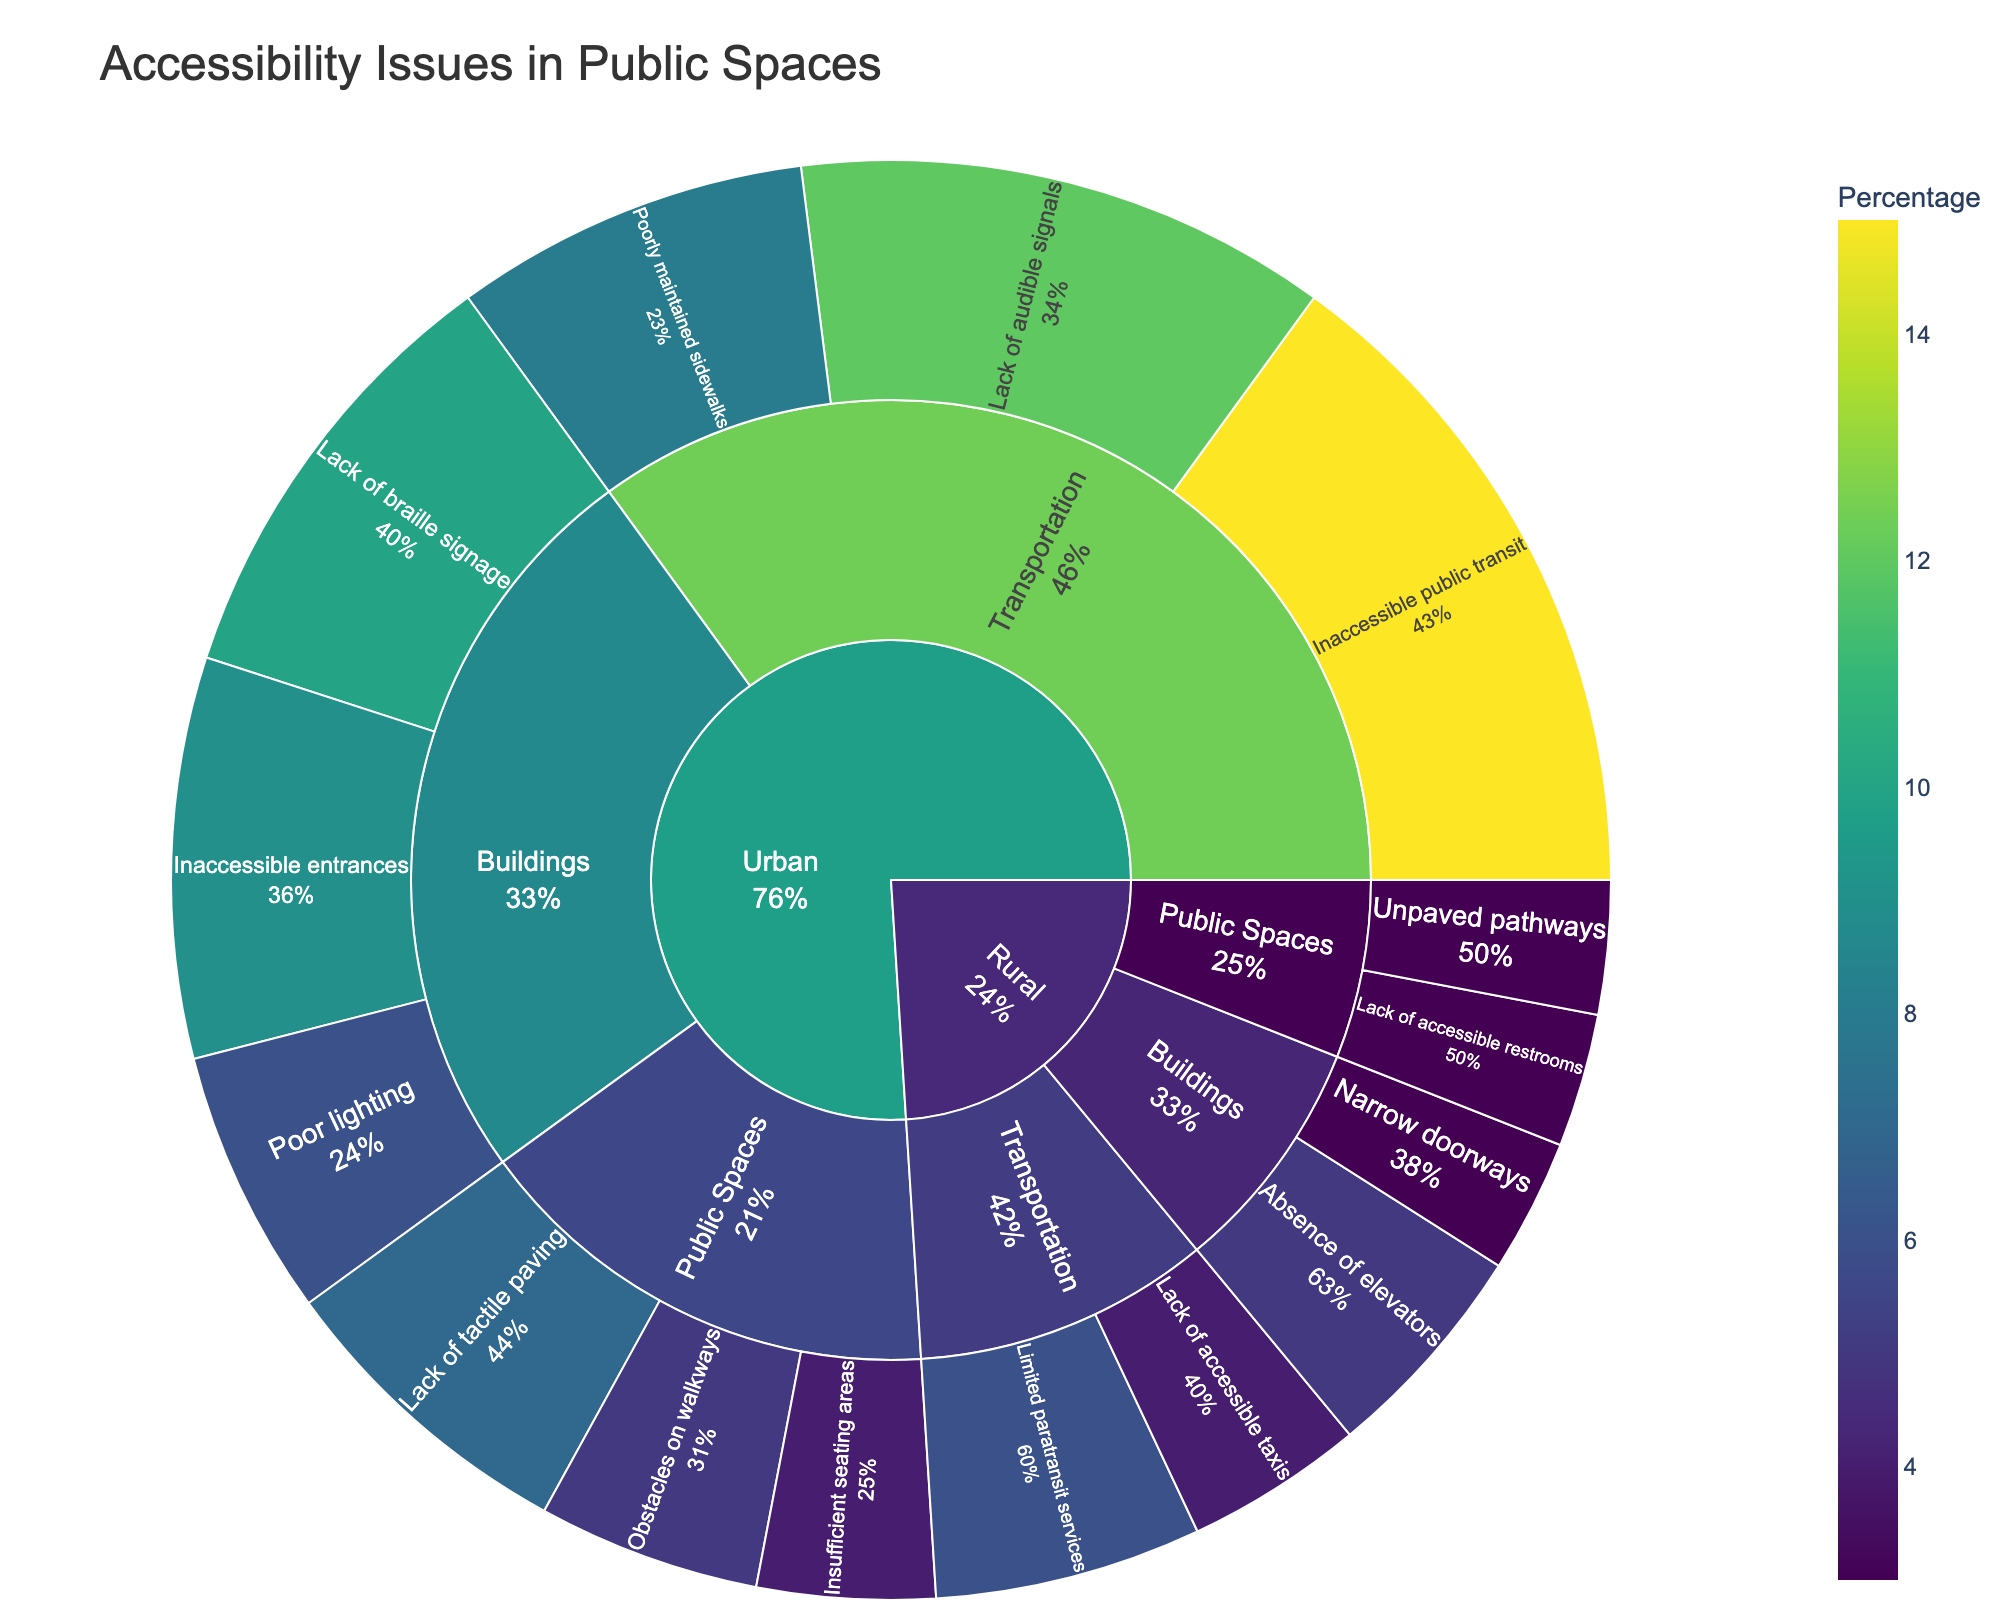What is the title of the plot? The title of the plot is displayed prominently at the top of the figure. It reads "Accessibility Issues in Public Spaces".
Answer: Accessibility Issues in Public Spaces Which location has the highest percentage of accessibility issues in public spaces, Urban or Rural? From the plot, you can observe that Urban areas have multiple categories and specific barriers leading to higher overall percentages compared to Rural areas. Adding up the values for Urban gives a higher total.
Answer: Urban What specific barrier has the highest percentage in the Transportation category in urban areas? In the Transportation category within Urban areas, the specific barrier with the highest percentage is "Inaccessible public transit" at 15%. You can identify this by tracing through the plot from Urban -> Transportation -> Inaccessible public transit.
Answer: Inaccessible public transit In Rural areas, what is the total percentage of accessibility issues in the Buildings category? The sum of the percentages in the Buildings category for Rural areas is calculated by adding up the percentages of "Absence of elevators" (5) and "Narrow doorways" (3). Thus, 5 + 3 = 8.
Answer: 8 Between Urban and Rural areas, which has more diverse categories of accessibility issues in public spaces? By analyzing the number of distinct paths branching out from each location (Urban and Rural), it is clear that Urban areas have more diverse categories as they contain more distinct categories and specific barriers.
Answer: Urban What is the combined percentage of accessibility issues for "Lack of braille signage" and "Inaccessible entrances" in urban buildings? For Urban buildings, sum the percentages of "Lack of braille signage" (10) and "Inaccessible entrances" (9). Thus, 10 + 9 = 19.
Answer: 19 Which category in rural areas has the lowest combined percentage of issues, Buildings or Public Spaces? In Rural areas, the combined percentages are Buildings (5+3=8) and Public Spaces (3+3=6). Hence, Public Spaces has the lower combined percentage (6).
Answer: Public Spaces What percentage of Urban transportation issues is due to the lack of audible signals? In the Urban -> Transportation category, the specific barrier "Lack of audible signals" contributes 12%. This is identified by following the path Urban -> Transportation -> Lack of audible signals.
Answer: 12 Is the percentage of unpaved pathways in rural public spaces higher or lower than the percentage of obstacles on walkways in urban public spaces? Comparing the values directly from the plot, "Unpaved pathways" in Rural Public Spaces is 3%, while "Obstacles on walkways" in Urban Public Spaces is 5%. Thus, 3 is lower than 5.
Answer: Lower 